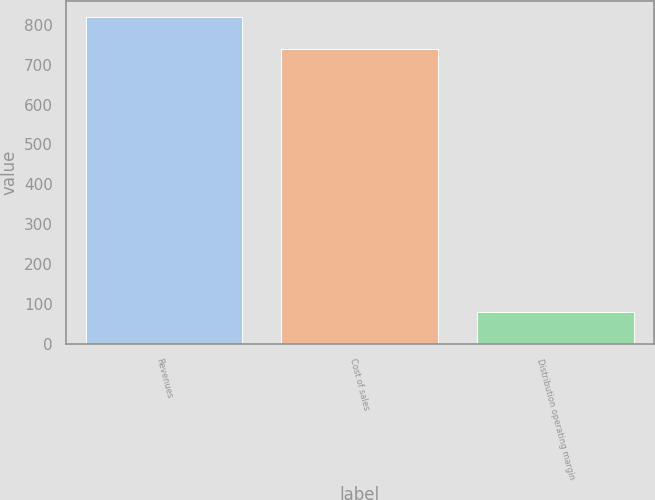Convert chart. <chart><loc_0><loc_0><loc_500><loc_500><bar_chart><fcel>Revenues<fcel>Cost of sales<fcel>Distribution operating margin<nl><fcel>819.1<fcel>739.3<fcel>79.8<nl></chart> 